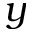Convert formula to latex. <formula><loc_0><loc_0><loc_500><loc_500>y</formula> 